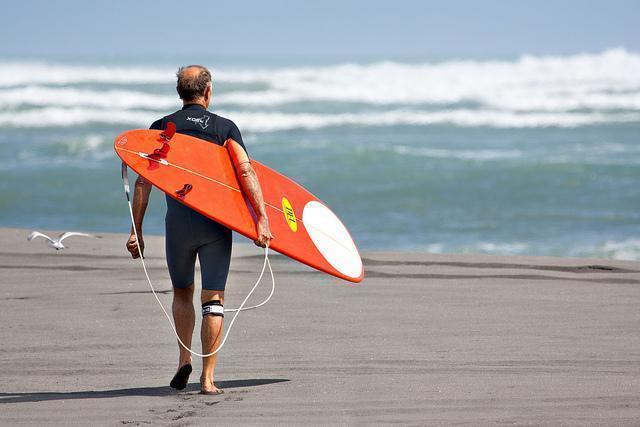What is the cable on the man's leg called?
Select the accurate answer and provide justification: `Answer: choice
Rationale: srationale.`
Options: Locker, surfboard leash, straps, usb cable. Answer: surfboard leash.
Rationale: The leash is for the board. 